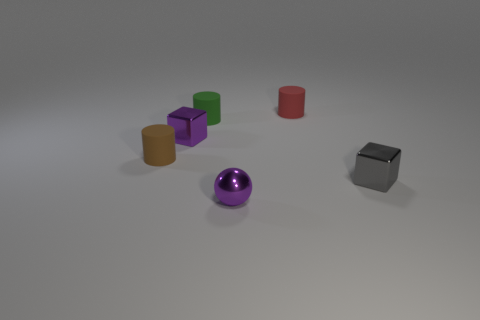Could this arrangement of objects represent something in a real-world scenario? Certainly, the geometric shapes, while seemingly randomly placed, could be seen as a modern art sculpture or an educational tool used to teach geometry, encouraging observers to compare shapes and sizes. What do the colors of the objects tell us about this image? The varied colors of the objects, from vivid purple to muted green, may suggest a deliberate choice to either showcase contrasting hues for visual appeal or possibly to code information, like categorizing or highlighting different properties of each shape. 